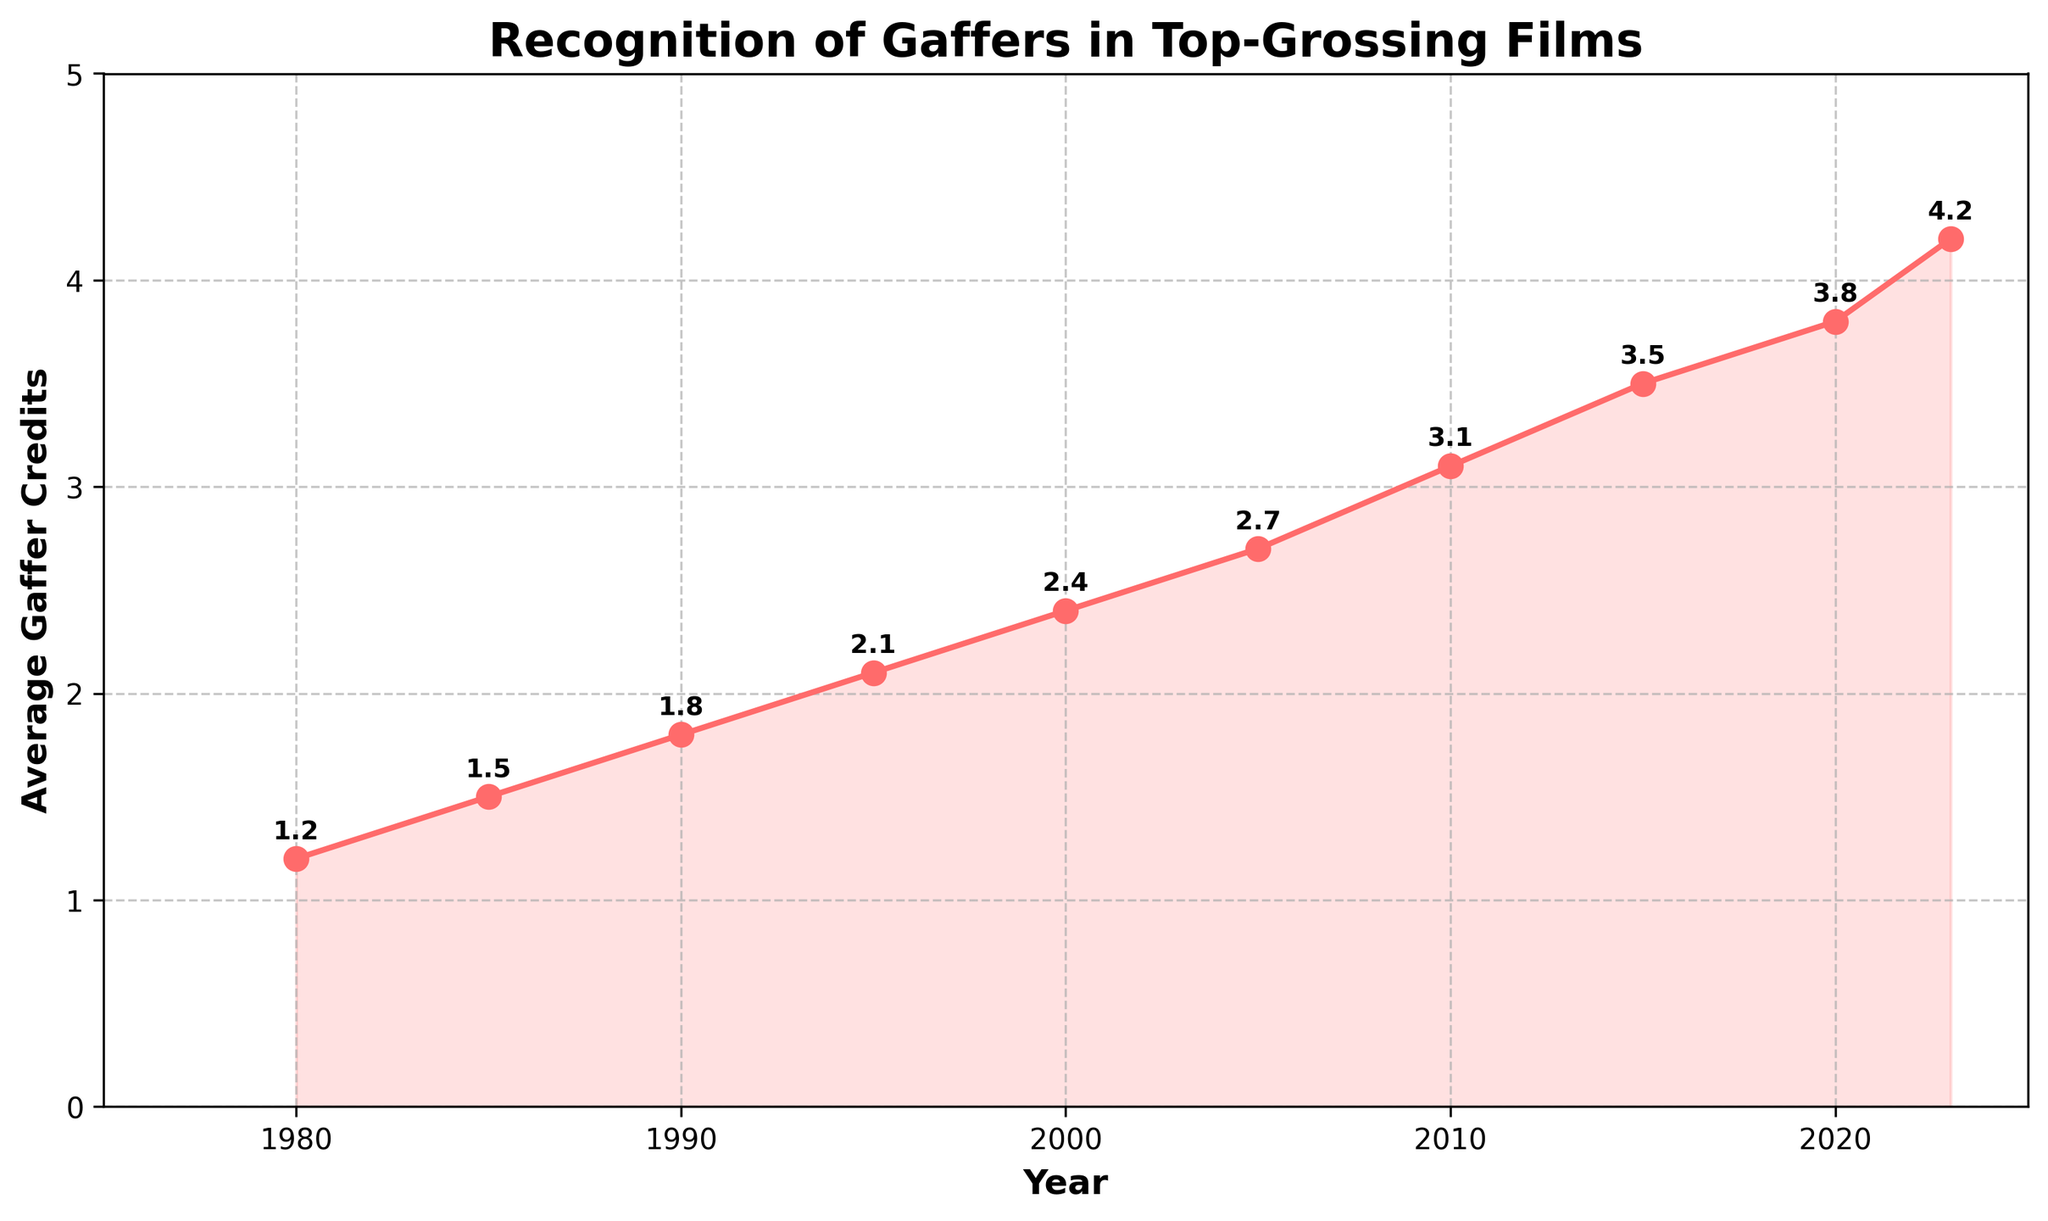What is the trend in the number of average gaffer credits from 1980 to 2023? The number of average gaffer credits consistently increases over time from 1980 to 2023. It starts at 1.2 in 1980 and rises to 4.2 by 2023.
Answer: Increasing trend Which year experienced the highest number of average gaffer credits? The figure shows that the highest number of average gaffer credits is in 2023, with a value of 4.2.
Answer: 2023 How much did the average gaffer credits increase between 1990 and 2020? To find the increase, subtract the 1990 value from the 2020 value: 3.8 - 1.8 = 2.0.
Answer: 2.0 What is the average number of gaffer credits in the years 1980, 2000, and 2023 combined? Add the values for these years and divide by 3: (1.2 + 2.4 + 4.2) / 3 = 7.8 / 3 = 2.6.
Answer: 2.6 Between which two consecutive decades does the largest increase in average gaffer credits occur? Compare the increases between consecutive decades: 1980-1990 (+0.6), 1990-2000 (+0.6), 2000-2010 (+0.7), 2010-2020 (+0.7), and 2020-2023 (+0.4). The largest increase is between 2000 and 2010 and also between 2010 and 2020, both with an increase of 0.7.
Answer: 2000-2010 and 2010-2020 Which year had an average gaffer credit closest to 2? Looking at the plot, 1995 has an average gaffer credit closest to 2 with a value of 2.1.
Answer: 1995 What is the percent increase in average gaffer credits from 1980 to 2023? Calculate the percent increase: \[((4.2 - 1.2) / 1.2) \times 100 = 250\%\]
Answer: 250% If the trend continues, what would be the expected average gaffer credits in 2025? Extrapolate the trend line; from 2020 to 2023, an average increase of 0.4 credits occurred. Assuming a similar increase, the expected average in 2025 would be approximately \(4.2 + 0.2 = 4.4\).
Answer: 4.4 